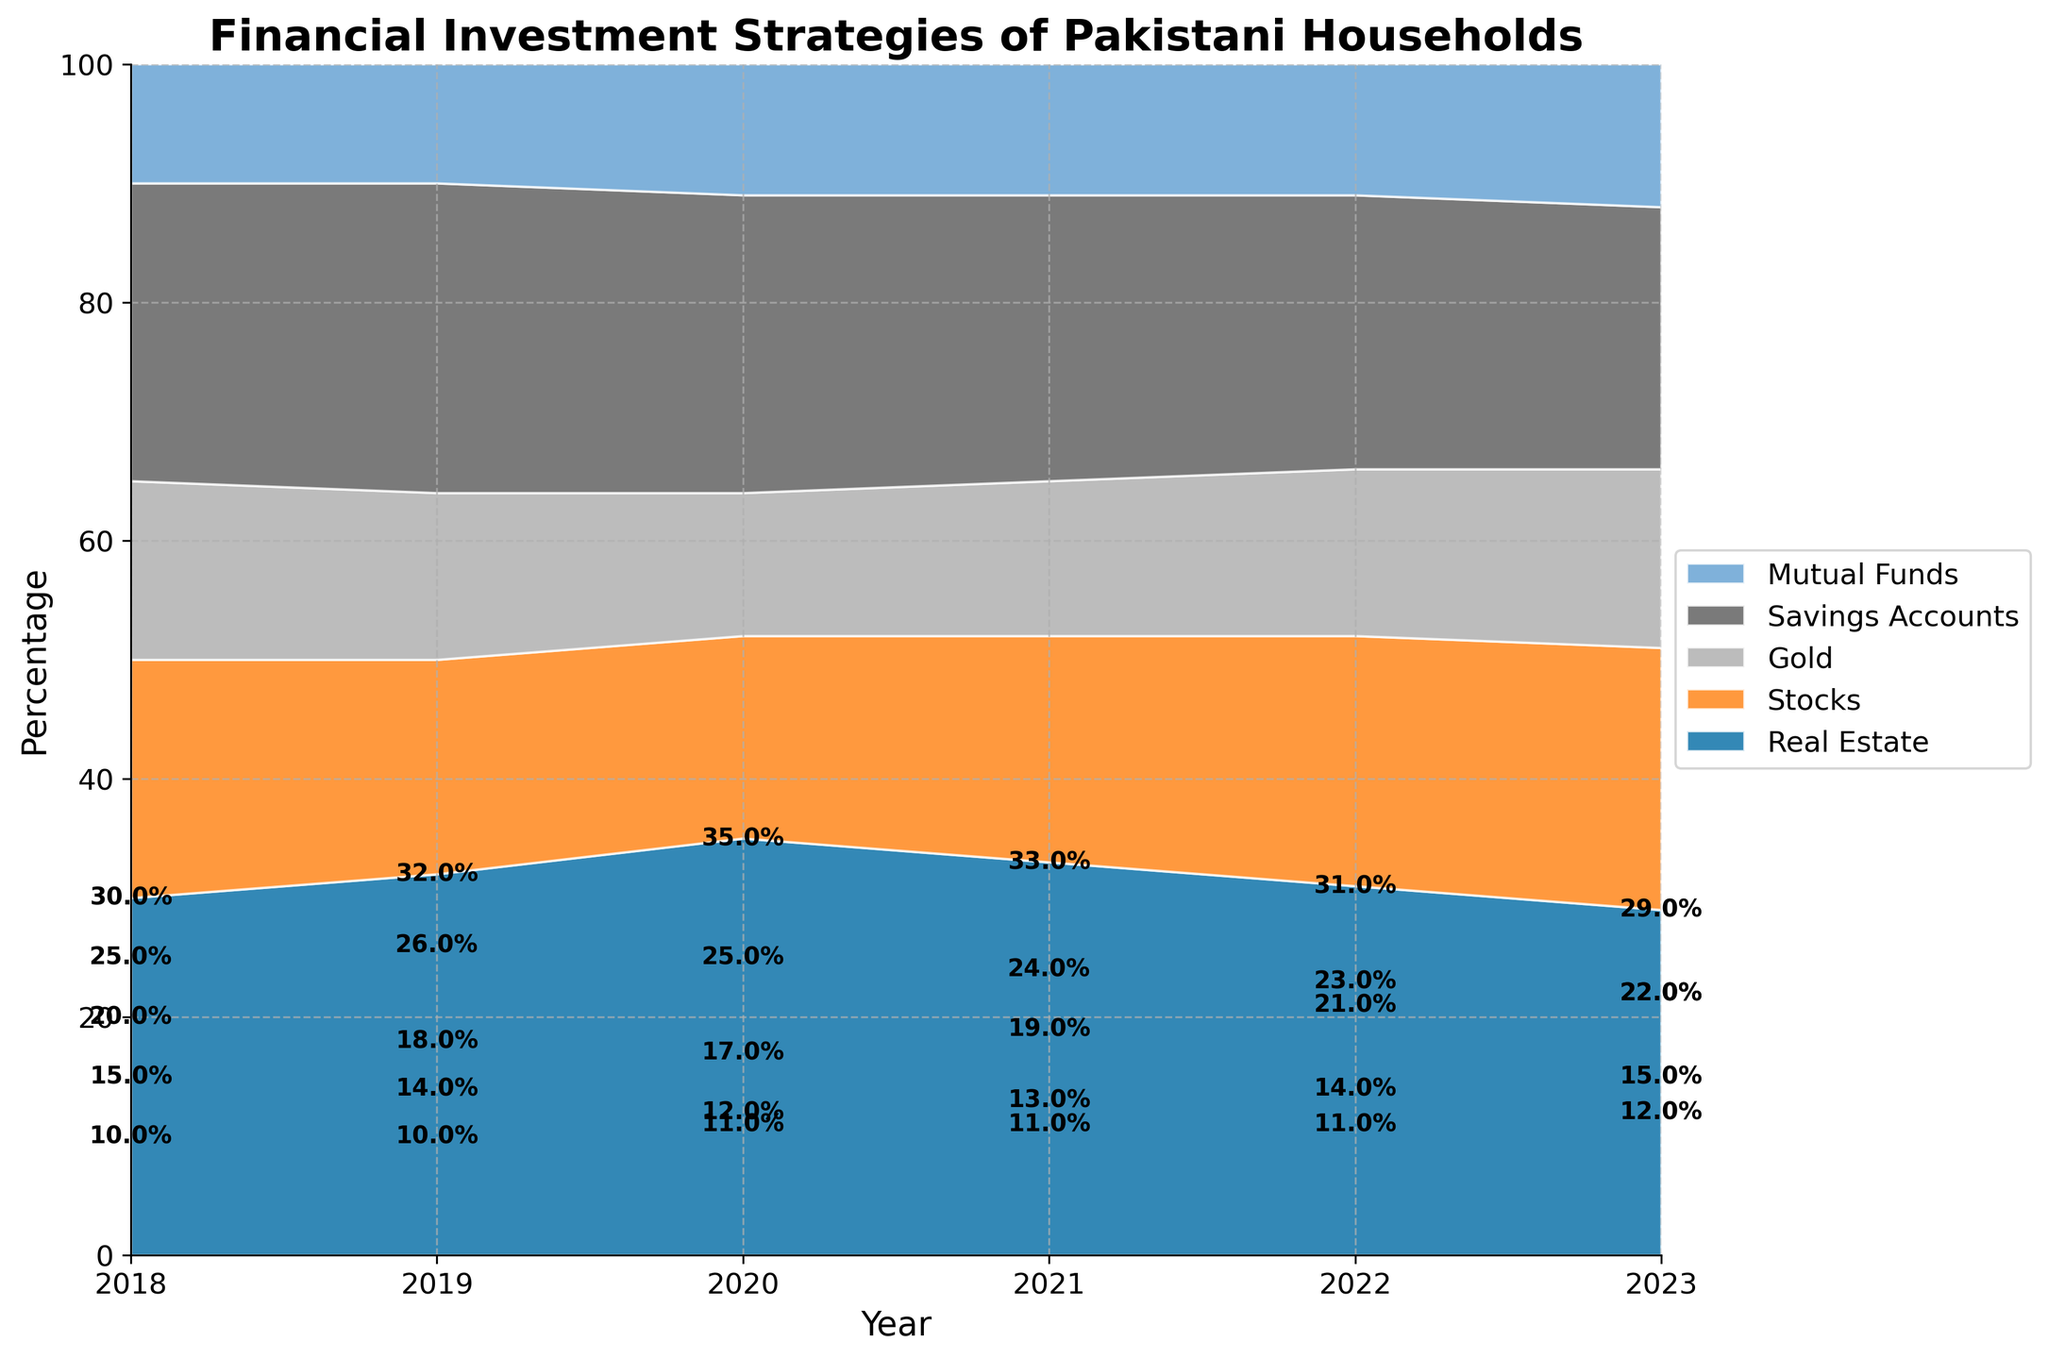What is the title of the chart? The title of the chart is usually found at the top of the figure. In this case, it is "Financial Investment Strategies of Pakistani Households."
Answer: Financial Investment Strategies of Pakistani Households Which asset type had the highest percentage investment in 2021? By visually inspecting the chart for the year 2021, identify the area with the largest section. For 2021, the largest section corresponds to Real Estate.
Answer: Real Estate How does the percentage of investment in Stocks change from 2018 to 2023? Observe the Stocks section from 2018 to 2023. Note the values and the trend: in 2018, it starts at 20%, then drops to 18%, 17%, and rises to 19%, 21%, and finally 22% in 2023.
Answer: It increases In which year did Pakistani households invest the least in Gold? Examine the Gold area in each year and compare the sizes. The smallest section for Gold appears in 2020.
Answer: 2020 Which two asset types showed an increasing trend in investment over the years? Identify which areas become larger over time. Stocks and Mutual Funds show a clear increasing trend overall.
Answer: Stocks and Mutual Funds What was the percentage of investment in Savings Accounts in 2022? Locate the Savings Accounts area for the year 2022 and read the percentage. It shows 23% in 2022.
Answer: 23% Compare the percentage of investment in Real Estate and Savings Accounts in 2020. Which one is higher and by how much? For 2020, find the percentages for Real Estate (35%) and Savings Accounts (25%). Subtract to find the difference. 35% - 25% = 10%.
Answer: Real Estate is higher by 10% What is the overall trend for investment in Real Estate from 2018 to 2023? Observe the Real Estate section from 2018 to 2023. It starts high, slightly increases, then decreases toward 2023.
Answer: Decreasing In which year did investment in Mutual Funds first reach 12%? Check the Mutual Funds area for each year and find the first year it reaches 12%. It reaches 12% in 2023.
Answer: 2023 Which asset type consistently had the lowest percentage of investment over the years? Identify the asset type with the smallest sections vertically through all years. Mutual Funds have consistently the lowest percentages.
Answer: Mutual Funds 